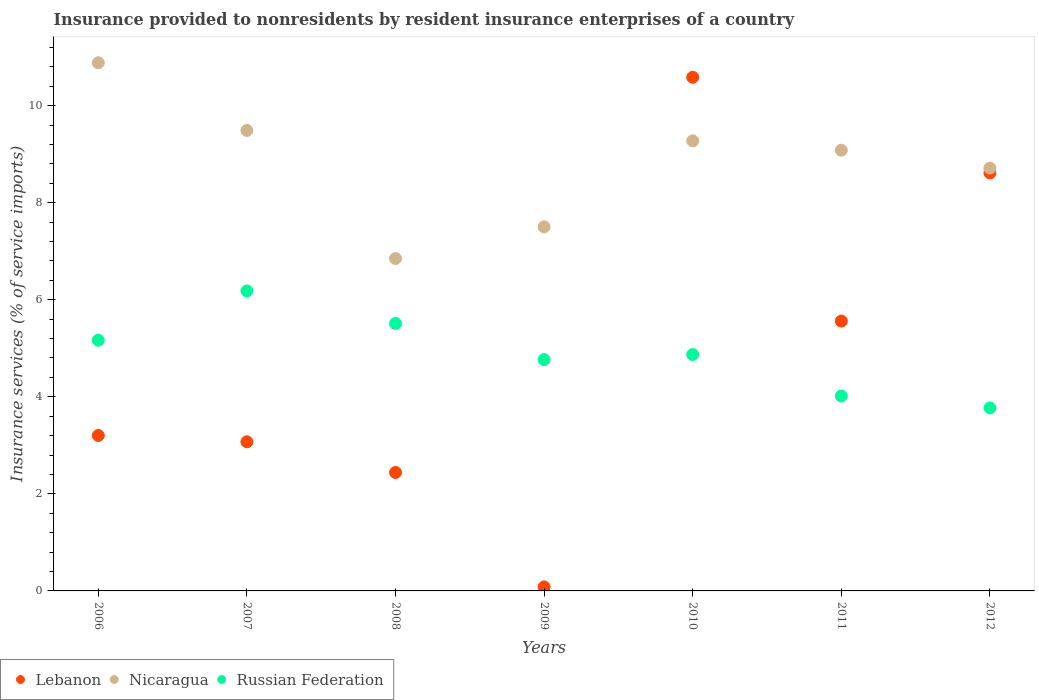How many different coloured dotlines are there?
Give a very brief answer. 3. Is the number of dotlines equal to the number of legend labels?
Ensure brevity in your answer.  Yes. What is the insurance provided to nonresidents in Russian Federation in 2012?
Give a very brief answer. 3.77. Across all years, what is the maximum insurance provided to nonresidents in Nicaragua?
Give a very brief answer. 10.88. Across all years, what is the minimum insurance provided to nonresidents in Russian Federation?
Make the answer very short. 3.77. In which year was the insurance provided to nonresidents in Nicaragua maximum?
Your response must be concise. 2006. In which year was the insurance provided to nonresidents in Lebanon minimum?
Provide a short and direct response. 2009. What is the total insurance provided to nonresidents in Lebanon in the graph?
Your answer should be compact. 33.56. What is the difference between the insurance provided to nonresidents in Lebanon in 2009 and that in 2011?
Your answer should be very brief. -5.48. What is the difference between the insurance provided to nonresidents in Russian Federation in 2009 and the insurance provided to nonresidents in Lebanon in 2012?
Keep it short and to the point. -3.85. What is the average insurance provided to nonresidents in Lebanon per year?
Offer a terse response. 4.79. In the year 2006, what is the difference between the insurance provided to nonresidents in Russian Federation and insurance provided to nonresidents in Lebanon?
Keep it short and to the point. 1.96. In how many years, is the insurance provided to nonresidents in Nicaragua greater than 4.8 %?
Your response must be concise. 7. What is the ratio of the insurance provided to nonresidents in Lebanon in 2006 to that in 2012?
Offer a very short reply. 0.37. Is the difference between the insurance provided to nonresidents in Russian Federation in 2007 and 2011 greater than the difference between the insurance provided to nonresidents in Lebanon in 2007 and 2011?
Offer a terse response. Yes. What is the difference between the highest and the second highest insurance provided to nonresidents in Russian Federation?
Give a very brief answer. 0.67. What is the difference between the highest and the lowest insurance provided to nonresidents in Russian Federation?
Keep it short and to the point. 2.41. In how many years, is the insurance provided to nonresidents in Nicaragua greater than the average insurance provided to nonresidents in Nicaragua taken over all years?
Keep it short and to the point. 4. Is the sum of the insurance provided to nonresidents in Russian Federation in 2010 and 2011 greater than the maximum insurance provided to nonresidents in Nicaragua across all years?
Offer a terse response. No. Is the insurance provided to nonresidents in Russian Federation strictly greater than the insurance provided to nonresidents in Nicaragua over the years?
Your answer should be compact. No. What is the difference between two consecutive major ticks on the Y-axis?
Your response must be concise. 2. Does the graph contain any zero values?
Your answer should be very brief. No. How are the legend labels stacked?
Provide a short and direct response. Horizontal. What is the title of the graph?
Ensure brevity in your answer.  Insurance provided to nonresidents by resident insurance enterprises of a country. Does "Comoros" appear as one of the legend labels in the graph?
Your answer should be very brief. No. What is the label or title of the Y-axis?
Your response must be concise. Insurance services (% of service imports). What is the Insurance services (% of service imports) of Lebanon in 2006?
Give a very brief answer. 3.2. What is the Insurance services (% of service imports) of Nicaragua in 2006?
Make the answer very short. 10.88. What is the Insurance services (% of service imports) of Russian Federation in 2006?
Offer a very short reply. 5.17. What is the Insurance services (% of service imports) of Lebanon in 2007?
Provide a succinct answer. 3.07. What is the Insurance services (% of service imports) in Nicaragua in 2007?
Offer a terse response. 9.49. What is the Insurance services (% of service imports) in Russian Federation in 2007?
Offer a terse response. 6.18. What is the Insurance services (% of service imports) of Lebanon in 2008?
Provide a short and direct response. 2.44. What is the Insurance services (% of service imports) in Nicaragua in 2008?
Provide a succinct answer. 6.85. What is the Insurance services (% of service imports) in Russian Federation in 2008?
Offer a terse response. 5.51. What is the Insurance services (% of service imports) in Lebanon in 2009?
Keep it short and to the point. 0.08. What is the Insurance services (% of service imports) of Nicaragua in 2009?
Keep it short and to the point. 7.5. What is the Insurance services (% of service imports) of Russian Federation in 2009?
Offer a terse response. 4.77. What is the Insurance services (% of service imports) in Lebanon in 2010?
Provide a succinct answer. 10.58. What is the Insurance services (% of service imports) of Nicaragua in 2010?
Give a very brief answer. 9.27. What is the Insurance services (% of service imports) of Russian Federation in 2010?
Your response must be concise. 4.87. What is the Insurance services (% of service imports) in Lebanon in 2011?
Provide a short and direct response. 5.56. What is the Insurance services (% of service imports) of Nicaragua in 2011?
Your answer should be compact. 9.08. What is the Insurance services (% of service imports) in Russian Federation in 2011?
Your answer should be compact. 4.02. What is the Insurance services (% of service imports) of Lebanon in 2012?
Offer a very short reply. 8.61. What is the Insurance services (% of service imports) in Nicaragua in 2012?
Give a very brief answer. 8.71. What is the Insurance services (% of service imports) of Russian Federation in 2012?
Give a very brief answer. 3.77. Across all years, what is the maximum Insurance services (% of service imports) of Lebanon?
Your answer should be compact. 10.58. Across all years, what is the maximum Insurance services (% of service imports) of Nicaragua?
Offer a very short reply. 10.88. Across all years, what is the maximum Insurance services (% of service imports) of Russian Federation?
Provide a short and direct response. 6.18. Across all years, what is the minimum Insurance services (% of service imports) in Lebanon?
Provide a short and direct response. 0.08. Across all years, what is the minimum Insurance services (% of service imports) of Nicaragua?
Provide a succinct answer. 6.85. Across all years, what is the minimum Insurance services (% of service imports) in Russian Federation?
Your response must be concise. 3.77. What is the total Insurance services (% of service imports) in Lebanon in the graph?
Make the answer very short. 33.56. What is the total Insurance services (% of service imports) of Nicaragua in the graph?
Give a very brief answer. 61.79. What is the total Insurance services (% of service imports) in Russian Federation in the graph?
Offer a terse response. 34.29. What is the difference between the Insurance services (% of service imports) in Lebanon in 2006 and that in 2007?
Ensure brevity in your answer.  0.13. What is the difference between the Insurance services (% of service imports) in Nicaragua in 2006 and that in 2007?
Provide a short and direct response. 1.39. What is the difference between the Insurance services (% of service imports) in Russian Federation in 2006 and that in 2007?
Your answer should be very brief. -1.02. What is the difference between the Insurance services (% of service imports) of Lebanon in 2006 and that in 2008?
Provide a succinct answer. 0.76. What is the difference between the Insurance services (% of service imports) in Nicaragua in 2006 and that in 2008?
Your answer should be very brief. 4.03. What is the difference between the Insurance services (% of service imports) of Russian Federation in 2006 and that in 2008?
Give a very brief answer. -0.35. What is the difference between the Insurance services (% of service imports) in Lebanon in 2006 and that in 2009?
Keep it short and to the point. 3.12. What is the difference between the Insurance services (% of service imports) of Nicaragua in 2006 and that in 2009?
Provide a short and direct response. 3.38. What is the difference between the Insurance services (% of service imports) of Russian Federation in 2006 and that in 2009?
Provide a short and direct response. 0.4. What is the difference between the Insurance services (% of service imports) in Lebanon in 2006 and that in 2010?
Offer a very short reply. -7.38. What is the difference between the Insurance services (% of service imports) in Nicaragua in 2006 and that in 2010?
Make the answer very short. 1.61. What is the difference between the Insurance services (% of service imports) of Russian Federation in 2006 and that in 2010?
Keep it short and to the point. 0.3. What is the difference between the Insurance services (% of service imports) in Lebanon in 2006 and that in 2011?
Give a very brief answer. -2.36. What is the difference between the Insurance services (% of service imports) in Nicaragua in 2006 and that in 2011?
Keep it short and to the point. 1.8. What is the difference between the Insurance services (% of service imports) of Russian Federation in 2006 and that in 2011?
Give a very brief answer. 1.15. What is the difference between the Insurance services (% of service imports) in Lebanon in 2006 and that in 2012?
Your answer should be compact. -5.41. What is the difference between the Insurance services (% of service imports) in Nicaragua in 2006 and that in 2012?
Make the answer very short. 2.17. What is the difference between the Insurance services (% of service imports) of Russian Federation in 2006 and that in 2012?
Offer a terse response. 1.4. What is the difference between the Insurance services (% of service imports) in Lebanon in 2007 and that in 2008?
Your answer should be compact. 0.63. What is the difference between the Insurance services (% of service imports) in Nicaragua in 2007 and that in 2008?
Make the answer very short. 2.64. What is the difference between the Insurance services (% of service imports) in Russian Federation in 2007 and that in 2008?
Your response must be concise. 0.67. What is the difference between the Insurance services (% of service imports) of Lebanon in 2007 and that in 2009?
Give a very brief answer. 2.99. What is the difference between the Insurance services (% of service imports) in Nicaragua in 2007 and that in 2009?
Give a very brief answer. 1.99. What is the difference between the Insurance services (% of service imports) in Russian Federation in 2007 and that in 2009?
Offer a terse response. 1.41. What is the difference between the Insurance services (% of service imports) in Lebanon in 2007 and that in 2010?
Provide a succinct answer. -7.51. What is the difference between the Insurance services (% of service imports) in Nicaragua in 2007 and that in 2010?
Your response must be concise. 0.21. What is the difference between the Insurance services (% of service imports) in Russian Federation in 2007 and that in 2010?
Offer a very short reply. 1.31. What is the difference between the Insurance services (% of service imports) of Lebanon in 2007 and that in 2011?
Provide a short and direct response. -2.49. What is the difference between the Insurance services (% of service imports) of Nicaragua in 2007 and that in 2011?
Keep it short and to the point. 0.41. What is the difference between the Insurance services (% of service imports) of Russian Federation in 2007 and that in 2011?
Your answer should be compact. 2.17. What is the difference between the Insurance services (% of service imports) of Lebanon in 2007 and that in 2012?
Your answer should be compact. -5.54. What is the difference between the Insurance services (% of service imports) of Nicaragua in 2007 and that in 2012?
Provide a succinct answer. 0.78. What is the difference between the Insurance services (% of service imports) of Russian Federation in 2007 and that in 2012?
Offer a very short reply. 2.41. What is the difference between the Insurance services (% of service imports) of Lebanon in 2008 and that in 2009?
Provide a succinct answer. 2.36. What is the difference between the Insurance services (% of service imports) in Nicaragua in 2008 and that in 2009?
Your answer should be very brief. -0.65. What is the difference between the Insurance services (% of service imports) of Russian Federation in 2008 and that in 2009?
Make the answer very short. 0.75. What is the difference between the Insurance services (% of service imports) in Lebanon in 2008 and that in 2010?
Your answer should be compact. -8.14. What is the difference between the Insurance services (% of service imports) in Nicaragua in 2008 and that in 2010?
Give a very brief answer. -2.43. What is the difference between the Insurance services (% of service imports) of Russian Federation in 2008 and that in 2010?
Offer a very short reply. 0.64. What is the difference between the Insurance services (% of service imports) of Lebanon in 2008 and that in 2011?
Make the answer very short. -3.12. What is the difference between the Insurance services (% of service imports) in Nicaragua in 2008 and that in 2011?
Keep it short and to the point. -2.23. What is the difference between the Insurance services (% of service imports) of Russian Federation in 2008 and that in 2011?
Your answer should be compact. 1.5. What is the difference between the Insurance services (% of service imports) in Lebanon in 2008 and that in 2012?
Ensure brevity in your answer.  -6.17. What is the difference between the Insurance services (% of service imports) in Nicaragua in 2008 and that in 2012?
Keep it short and to the point. -1.86. What is the difference between the Insurance services (% of service imports) in Russian Federation in 2008 and that in 2012?
Offer a very short reply. 1.74. What is the difference between the Insurance services (% of service imports) in Lebanon in 2009 and that in 2010?
Provide a short and direct response. -10.5. What is the difference between the Insurance services (% of service imports) in Nicaragua in 2009 and that in 2010?
Keep it short and to the point. -1.77. What is the difference between the Insurance services (% of service imports) in Russian Federation in 2009 and that in 2010?
Keep it short and to the point. -0.1. What is the difference between the Insurance services (% of service imports) of Lebanon in 2009 and that in 2011?
Give a very brief answer. -5.48. What is the difference between the Insurance services (% of service imports) of Nicaragua in 2009 and that in 2011?
Keep it short and to the point. -1.58. What is the difference between the Insurance services (% of service imports) in Russian Federation in 2009 and that in 2011?
Your response must be concise. 0.75. What is the difference between the Insurance services (% of service imports) in Lebanon in 2009 and that in 2012?
Keep it short and to the point. -8.53. What is the difference between the Insurance services (% of service imports) of Nicaragua in 2009 and that in 2012?
Your response must be concise. -1.21. What is the difference between the Insurance services (% of service imports) in Russian Federation in 2009 and that in 2012?
Offer a terse response. 1. What is the difference between the Insurance services (% of service imports) of Lebanon in 2010 and that in 2011?
Your answer should be compact. 5.02. What is the difference between the Insurance services (% of service imports) in Nicaragua in 2010 and that in 2011?
Make the answer very short. 0.19. What is the difference between the Insurance services (% of service imports) of Russian Federation in 2010 and that in 2011?
Keep it short and to the point. 0.86. What is the difference between the Insurance services (% of service imports) of Lebanon in 2010 and that in 2012?
Your answer should be very brief. 1.97. What is the difference between the Insurance services (% of service imports) in Nicaragua in 2010 and that in 2012?
Your answer should be very brief. 0.56. What is the difference between the Insurance services (% of service imports) of Russian Federation in 2010 and that in 2012?
Provide a succinct answer. 1.1. What is the difference between the Insurance services (% of service imports) in Lebanon in 2011 and that in 2012?
Provide a succinct answer. -3.05. What is the difference between the Insurance services (% of service imports) of Nicaragua in 2011 and that in 2012?
Your answer should be very brief. 0.37. What is the difference between the Insurance services (% of service imports) of Russian Federation in 2011 and that in 2012?
Provide a short and direct response. 0.24. What is the difference between the Insurance services (% of service imports) in Lebanon in 2006 and the Insurance services (% of service imports) in Nicaragua in 2007?
Offer a very short reply. -6.29. What is the difference between the Insurance services (% of service imports) in Lebanon in 2006 and the Insurance services (% of service imports) in Russian Federation in 2007?
Your response must be concise. -2.98. What is the difference between the Insurance services (% of service imports) in Nicaragua in 2006 and the Insurance services (% of service imports) in Russian Federation in 2007?
Your response must be concise. 4.7. What is the difference between the Insurance services (% of service imports) in Lebanon in 2006 and the Insurance services (% of service imports) in Nicaragua in 2008?
Give a very brief answer. -3.65. What is the difference between the Insurance services (% of service imports) in Lebanon in 2006 and the Insurance services (% of service imports) in Russian Federation in 2008?
Keep it short and to the point. -2.31. What is the difference between the Insurance services (% of service imports) in Nicaragua in 2006 and the Insurance services (% of service imports) in Russian Federation in 2008?
Offer a very short reply. 5.37. What is the difference between the Insurance services (% of service imports) in Lebanon in 2006 and the Insurance services (% of service imports) in Nicaragua in 2009?
Ensure brevity in your answer.  -4.3. What is the difference between the Insurance services (% of service imports) in Lebanon in 2006 and the Insurance services (% of service imports) in Russian Federation in 2009?
Offer a terse response. -1.56. What is the difference between the Insurance services (% of service imports) of Nicaragua in 2006 and the Insurance services (% of service imports) of Russian Federation in 2009?
Offer a terse response. 6.12. What is the difference between the Insurance services (% of service imports) of Lebanon in 2006 and the Insurance services (% of service imports) of Nicaragua in 2010?
Make the answer very short. -6.07. What is the difference between the Insurance services (% of service imports) in Lebanon in 2006 and the Insurance services (% of service imports) in Russian Federation in 2010?
Make the answer very short. -1.67. What is the difference between the Insurance services (% of service imports) in Nicaragua in 2006 and the Insurance services (% of service imports) in Russian Federation in 2010?
Your response must be concise. 6.01. What is the difference between the Insurance services (% of service imports) in Lebanon in 2006 and the Insurance services (% of service imports) in Nicaragua in 2011?
Offer a very short reply. -5.88. What is the difference between the Insurance services (% of service imports) in Lebanon in 2006 and the Insurance services (% of service imports) in Russian Federation in 2011?
Keep it short and to the point. -0.81. What is the difference between the Insurance services (% of service imports) in Nicaragua in 2006 and the Insurance services (% of service imports) in Russian Federation in 2011?
Make the answer very short. 6.87. What is the difference between the Insurance services (% of service imports) of Lebanon in 2006 and the Insurance services (% of service imports) of Nicaragua in 2012?
Your response must be concise. -5.51. What is the difference between the Insurance services (% of service imports) of Lebanon in 2006 and the Insurance services (% of service imports) of Russian Federation in 2012?
Ensure brevity in your answer.  -0.57. What is the difference between the Insurance services (% of service imports) in Nicaragua in 2006 and the Insurance services (% of service imports) in Russian Federation in 2012?
Provide a succinct answer. 7.11. What is the difference between the Insurance services (% of service imports) in Lebanon in 2007 and the Insurance services (% of service imports) in Nicaragua in 2008?
Offer a very short reply. -3.78. What is the difference between the Insurance services (% of service imports) in Lebanon in 2007 and the Insurance services (% of service imports) in Russian Federation in 2008?
Your answer should be very brief. -2.44. What is the difference between the Insurance services (% of service imports) in Nicaragua in 2007 and the Insurance services (% of service imports) in Russian Federation in 2008?
Keep it short and to the point. 3.98. What is the difference between the Insurance services (% of service imports) of Lebanon in 2007 and the Insurance services (% of service imports) of Nicaragua in 2009?
Provide a succinct answer. -4.43. What is the difference between the Insurance services (% of service imports) in Lebanon in 2007 and the Insurance services (% of service imports) in Russian Federation in 2009?
Ensure brevity in your answer.  -1.69. What is the difference between the Insurance services (% of service imports) of Nicaragua in 2007 and the Insurance services (% of service imports) of Russian Federation in 2009?
Your answer should be compact. 4.72. What is the difference between the Insurance services (% of service imports) of Lebanon in 2007 and the Insurance services (% of service imports) of Nicaragua in 2010?
Keep it short and to the point. -6.2. What is the difference between the Insurance services (% of service imports) of Lebanon in 2007 and the Insurance services (% of service imports) of Russian Federation in 2010?
Keep it short and to the point. -1.8. What is the difference between the Insurance services (% of service imports) in Nicaragua in 2007 and the Insurance services (% of service imports) in Russian Federation in 2010?
Provide a succinct answer. 4.62. What is the difference between the Insurance services (% of service imports) of Lebanon in 2007 and the Insurance services (% of service imports) of Nicaragua in 2011?
Offer a terse response. -6.01. What is the difference between the Insurance services (% of service imports) of Lebanon in 2007 and the Insurance services (% of service imports) of Russian Federation in 2011?
Make the answer very short. -0.94. What is the difference between the Insurance services (% of service imports) in Nicaragua in 2007 and the Insurance services (% of service imports) in Russian Federation in 2011?
Provide a succinct answer. 5.47. What is the difference between the Insurance services (% of service imports) in Lebanon in 2007 and the Insurance services (% of service imports) in Nicaragua in 2012?
Your answer should be very brief. -5.64. What is the difference between the Insurance services (% of service imports) of Lebanon in 2007 and the Insurance services (% of service imports) of Russian Federation in 2012?
Your answer should be very brief. -0.7. What is the difference between the Insurance services (% of service imports) in Nicaragua in 2007 and the Insurance services (% of service imports) in Russian Federation in 2012?
Your answer should be very brief. 5.72. What is the difference between the Insurance services (% of service imports) in Lebanon in 2008 and the Insurance services (% of service imports) in Nicaragua in 2009?
Offer a very short reply. -5.06. What is the difference between the Insurance services (% of service imports) in Lebanon in 2008 and the Insurance services (% of service imports) in Russian Federation in 2009?
Give a very brief answer. -2.33. What is the difference between the Insurance services (% of service imports) of Nicaragua in 2008 and the Insurance services (% of service imports) of Russian Federation in 2009?
Offer a terse response. 2.08. What is the difference between the Insurance services (% of service imports) in Lebanon in 2008 and the Insurance services (% of service imports) in Nicaragua in 2010?
Give a very brief answer. -6.83. What is the difference between the Insurance services (% of service imports) of Lebanon in 2008 and the Insurance services (% of service imports) of Russian Federation in 2010?
Provide a succinct answer. -2.43. What is the difference between the Insurance services (% of service imports) in Nicaragua in 2008 and the Insurance services (% of service imports) in Russian Federation in 2010?
Ensure brevity in your answer.  1.98. What is the difference between the Insurance services (% of service imports) in Lebanon in 2008 and the Insurance services (% of service imports) in Nicaragua in 2011?
Keep it short and to the point. -6.64. What is the difference between the Insurance services (% of service imports) in Lebanon in 2008 and the Insurance services (% of service imports) in Russian Federation in 2011?
Offer a very short reply. -1.57. What is the difference between the Insurance services (% of service imports) of Nicaragua in 2008 and the Insurance services (% of service imports) of Russian Federation in 2011?
Give a very brief answer. 2.83. What is the difference between the Insurance services (% of service imports) in Lebanon in 2008 and the Insurance services (% of service imports) in Nicaragua in 2012?
Make the answer very short. -6.27. What is the difference between the Insurance services (% of service imports) of Lebanon in 2008 and the Insurance services (% of service imports) of Russian Federation in 2012?
Provide a short and direct response. -1.33. What is the difference between the Insurance services (% of service imports) in Nicaragua in 2008 and the Insurance services (% of service imports) in Russian Federation in 2012?
Keep it short and to the point. 3.08. What is the difference between the Insurance services (% of service imports) of Lebanon in 2009 and the Insurance services (% of service imports) of Nicaragua in 2010?
Your response must be concise. -9.19. What is the difference between the Insurance services (% of service imports) in Lebanon in 2009 and the Insurance services (% of service imports) in Russian Federation in 2010?
Your answer should be compact. -4.79. What is the difference between the Insurance services (% of service imports) in Nicaragua in 2009 and the Insurance services (% of service imports) in Russian Federation in 2010?
Give a very brief answer. 2.63. What is the difference between the Insurance services (% of service imports) of Lebanon in 2009 and the Insurance services (% of service imports) of Nicaragua in 2011?
Keep it short and to the point. -9. What is the difference between the Insurance services (% of service imports) of Lebanon in 2009 and the Insurance services (% of service imports) of Russian Federation in 2011?
Make the answer very short. -3.93. What is the difference between the Insurance services (% of service imports) in Nicaragua in 2009 and the Insurance services (% of service imports) in Russian Federation in 2011?
Your answer should be very brief. 3.49. What is the difference between the Insurance services (% of service imports) of Lebanon in 2009 and the Insurance services (% of service imports) of Nicaragua in 2012?
Your answer should be very brief. -8.63. What is the difference between the Insurance services (% of service imports) of Lebanon in 2009 and the Insurance services (% of service imports) of Russian Federation in 2012?
Provide a short and direct response. -3.69. What is the difference between the Insurance services (% of service imports) in Nicaragua in 2009 and the Insurance services (% of service imports) in Russian Federation in 2012?
Ensure brevity in your answer.  3.73. What is the difference between the Insurance services (% of service imports) in Lebanon in 2010 and the Insurance services (% of service imports) in Nicaragua in 2011?
Make the answer very short. 1.5. What is the difference between the Insurance services (% of service imports) in Lebanon in 2010 and the Insurance services (% of service imports) in Russian Federation in 2011?
Make the answer very short. 6.57. What is the difference between the Insurance services (% of service imports) of Nicaragua in 2010 and the Insurance services (% of service imports) of Russian Federation in 2011?
Give a very brief answer. 5.26. What is the difference between the Insurance services (% of service imports) in Lebanon in 2010 and the Insurance services (% of service imports) in Nicaragua in 2012?
Provide a succinct answer. 1.87. What is the difference between the Insurance services (% of service imports) of Lebanon in 2010 and the Insurance services (% of service imports) of Russian Federation in 2012?
Your answer should be compact. 6.81. What is the difference between the Insurance services (% of service imports) in Nicaragua in 2010 and the Insurance services (% of service imports) in Russian Federation in 2012?
Keep it short and to the point. 5.5. What is the difference between the Insurance services (% of service imports) of Lebanon in 2011 and the Insurance services (% of service imports) of Nicaragua in 2012?
Your answer should be very brief. -3.15. What is the difference between the Insurance services (% of service imports) of Lebanon in 2011 and the Insurance services (% of service imports) of Russian Federation in 2012?
Your answer should be compact. 1.79. What is the difference between the Insurance services (% of service imports) of Nicaragua in 2011 and the Insurance services (% of service imports) of Russian Federation in 2012?
Your answer should be very brief. 5.31. What is the average Insurance services (% of service imports) in Lebanon per year?
Provide a short and direct response. 4.79. What is the average Insurance services (% of service imports) of Nicaragua per year?
Your answer should be very brief. 8.83. What is the average Insurance services (% of service imports) of Russian Federation per year?
Your response must be concise. 4.9. In the year 2006, what is the difference between the Insurance services (% of service imports) in Lebanon and Insurance services (% of service imports) in Nicaragua?
Give a very brief answer. -7.68. In the year 2006, what is the difference between the Insurance services (% of service imports) in Lebanon and Insurance services (% of service imports) in Russian Federation?
Keep it short and to the point. -1.96. In the year 2006, what is the difference between the Insurance services (% of service imports) in Nicaragua and Insurance services (% of service imports) in Russian Federation?
Offer a very short reply. 5.72. In the year 2007, what is the difference between the Insurance services (% of service imports) in Lebanon and Insurance services (% of service imports) in Nicaragua?
Ensure brevity in your answer.  -6.42. In the year 2007, what is the difference between the Insurance services (% of service imports) in Lebanon and Insurance services (% of service imports) in Russian Federation?
Offer a terse response. -3.11. In the year 2007, what is the difference between the Insurance services (% of service imports) in Nicaragua and Insurance services (% of service imports) in Russian Federation?
Your answer should be very brief. 3.31. In the year 2008, what is the difference between the Insurance services (% of service imports) in Lebanon and Insurance services (% of service imports) in Nicaragua?
Provide a succinct answer. -4.41. In the year 2008, what is the difference between the Insurance services (% of service imports) of Lebanon and Insurance services (% of service imports) of Russian Federation?
Provide a succinct answer. -3.07. In the year 2008, what is the difference between the Insurance services (% of service imports) of Nicaragua and Insurance services (% of service imports) of Russian Federation?
Offer a very short reply. 1.34. In the year 2009, what is the difference between the Insurance services (% of service imports) in Lebanon and Insurance services (% of service imports) in Nicaragua?
Make the answer very short. -7.42. In the year 2009, what is the difference between the Insurance services (% of service imports) in Lebanon and Insurance services (% of service imports) in Russian Federation?
Your answer should be compact. -4.68. In the year 2009, what is the difference between the Insurance services (% of service imports) in Nicaragua and Insurance services (% of service imports) in Russian Federation?
Your answer should be compact. 2.73. In the year 2010, what is the difference between the Insurance services (% of service imports) of Lebanon and Insurance services (% of service imports) of Nicaragua?
Your answer should be compact. 1.31. In the year 2010, what is the difference between the Insurance services (% of service imports) in Lebanon and Insurance services (% of service imports) in Russian Federation?
Keep it short and to the point. 5.71. In the year 2010, what is the difference between the Insurance services (% of service imports) of Nicaragua and Insurance services (% of service imports) of Russian Federation?
Keep it short and to the point. 4.4. In the year 2011, what is the difference between the Insurance services (% of service imports) of Lebanon and Insurance services (% of service imports) of Nicaragua?
Provide a succinct answer. -3.52. In the year 2011, what is the difference between the Insurance services (% of service imports) of Lebanon and Insurance services (% of service imports) of Russian Federation?
Your response must be concise. 1.55. In the year 2011, what is the difference between the Insurance services (% of service imports) of Nicaragua and Insurance services (% of service imports) of Russian Federation?
Keep it short and to the point. 5.07. In the year 2012, what is the difference between the Insurance services (% of service imports) of Lebanon and Insurance services (% of service imports) of Nicaragua?
Offer a very short reply. -0.1. In the year 2012, what is the difference between the Insurance services (% of service imports) in Lebanon and Insurance services (% of service imports) in Russian Federation?
Give a very brief answer. 4.84. In the year 2012, what is the difference between the Insurance services (% of service imports) of Nicaragua and Insurance services (% of service imports) of Russian Federation?
Offer a very short reply. 4.94. What is the ratio of the Insurance services (% of service imports) of Lebanon in 2006 to that in 2007?
Provide a succinct answer. 1.04. What is the ratio of the Insurance services (% of service imports) in Nicaragua in 2006 to that in 2007?
Your response must be concise. 1.15. What is the ratio of the Insurance services (% of service imports) in Russian Federation in 2006 to that in 2007?
Provide a succinct answer. 0.84. What is the ratio of the Insurance services (% of service imports) in Lebanon in 2006 to that in 2008?
Ensure brevity in your answer.  1.31. What is the ratio of the Insurance services (% of service imports) in Nicaragua in 2006 to that in 2008?
Make the answer very short. 1.59. What is the ratio of the Insurance services (% of service imports) of Russian Federation in 2006 to that in 2008?
Provide a succinct answer. 0.94. What is the ratio of the Insurance services (% of service imports) in Lebanon in 2006 to that in 2009?
Your answer should be compact. 38.35. What is the ratio of the Insurance services (% of service imports) of Nicaragua in 2006 to that in 2009?
Provide a short and direct response. 1.45. What is the ratio of the Insurance services (% of service imports) in Russian Federation in 2006 to that in 2009?
Provide a short and direct response. 1.08. What is the ratio of the Insurance services (% of service imports) of Lebanon in 2006 to that in 2010?
Your answer should be compact. 0.3. What is the ratio of the Insurance services (% of service imports) in Nicaragua in 2006 to that in 2010?
Your answer should be very brief. 1.17. What is the ratio of the Insurance services (% of service imports) in Russian Federation in 2006 to that in 2010?
Provide a short and direct response. 1.06. What is the ratio of the Insurance services (% of service imports) of Lebanon in 2006 to that in 2011?
Make the answer very short. 0.58. What is the ratio of the Insurance services (% of service imports) in Nicaragua in 2006 to that in 2011?
Offer a very short reply. 1.2. What is the ratio of the Insurance services (% of service imports) of Russian Federation in 2006 to that in 2011?
Your response must be concise. 1.29. What is the ratio of the Insurance services (% of service imports) of Lebanon in 2006 to that in 2012?
Give a very brief answer. 0.37. What is the ratio of the Insurance services (% of service imports) in Nicaragua in 2006 to that in 2012?
Keep it short and to the point. 1.25. What is the ratio of the Insurance services (% of service imports) in Russian Federation in 2006 to that in 2012?
Keep it short and to the point. 1.37. What is the ratio of the Insurance services (% of service imports) of Lebanon in 2007 to that in 2008?
Ensure brevity in your answer.  1.26. What is the ratio of the Insurance services (% of service imports) of Nicaragua in 2007 to that in 2008?
Your response must be concise. 1.39. What is the ratio of the Insurance services (% of service imports) of Russian Federation in 2007 to that in 2008?
Ensure brevity in your answer.  1.12. What is the ratio of the Insurance services (% of service imports) of Lebanon in 2007 to that in 2009?
Offer a very short reply. 36.79. What is the ratio of the Insurance services (% of service imports) of Nicaragua in 2007 to that in 2009?
Your answer should be very brief. 1.26. What is the ratio of the Insurance services (% of service imports) in Russian Federation in 2007 to that in 2009?
Your answer should be compact. 1.3. What is the ratio of the Insurance services (% of service imports) of Lebanon in 2007 to that in 2010?
Your answer should be compact. 0.29. What is the ratio of the Insurance services (% of service imports) of Nicaragua in 2007 to that in 2010?
Ensure brevity in your answer.  1.02. What is the ratio of the Insurance services (% of service imports) in Russian Federation in 2007 to that in 2010?
Keep it short and to the point. 1.27. What is the ratio of the Insurance services (% of service imports) in Lebanon in 2007 to that in 2011?
Your answer should be very brief. 0.55. What is the ratio of the Insurance services (% of service imports) in Nicaragua in 2007 to that in 2011?
Offer a very short reply. 1.04. What is the ratio of the Insurance services (% of service imports) of Russian Federation in 2007 to that in 2011?
Offer a very short reply. 1.54. What is the ratio of the Insurance services (% of service imports) of Lebanon in 2007 to that in 2012?
Provide a short and direct response. 0.36. What is the ratio of the Insurance services (% of service imports) in Nicaragua in 2007 to that in 2012?
Make the answer very short. 1.09. What is the ratio of the Insurance services (% of service imports) of Russian Federation in 2007 to that in 2012?
Your answer should be compact. 1.64. What is the ratio of the Insurance services (% of service imports) of Lebanon in 2008 to that in 2009?
Ensure brevity in your answer.  29.23. What is the ratio of the Insurance services (% of service imports) in Nicaragua in 2008 to that in 2009?
Your response must be concise. 0.91. What is the ratio of the Insurance services (% of service imports) of Russian Federation in 2008 to that in 2009?
Keep it short and to the point. 1.16. What is the ratio of the Insurance services (% of service imports) in Lebanon in 2008 to that in 2010?
Make the answer very short. 0.23. What is the ratio of the Insurance services (% of service imports) of Nicaragua in 2008 to that in 2010?
Offer a very short reply. 0.74. What is the ratio of the Insurance services (% of service imports) in Russian Federation in 2008 to that in 2010?
Your answer should be very brief. 1.13. What is the ratio of the Insurance services (% of service imports) of Lebanon in 2008 to that in 2011?
Ensure brevity in your answer.  0.44. What is the ratio of the Insurance services (% of service imports) of Nicaragua in 2008 to that in 2011?
Offer a terse response. 0.75. What is the ratio of the Insurance services (% of service imports) in Russian Federation in 2008 to that in 2011?
Your answer should be very brief. 1.37. What is the ratio of the Insurance services (% of service imports) of Lebanon in 2008 to that in 2012?
Give a very brief answer. 0.28. What is the ratio of the Insurance services (% of service imports) in Nicaragua in 2008 to that in 2012?
Your answer should be very brief. 0.79. What is the ratio of the Insurance services (% of service imports) of Russian Federation in 2008 to that in 2012?
Your answer should be very brief. 1.46. What is the ratio of the Insurance services (% of service imports) in Lebanon in 2009 to that in 2010?
Provide a succinct answer. 0.01. What is the ratio of the Insurance services (% of service imports) in Nicaragua in 2009 to that in 2010?
Your response must be concise. 0.81. What is the ratio of the Insurance services (% of service imports) of Russian Federation in 2009 to that in 2010?
Offer a terse response. 0.98. What is the ratio of the Insurance services (% of service imports) of Lebanon in 2009 to that in 2011?
Ensure brevity in your answer.  0.01. What is the ratio of the Insurance services (% of service imports) of Nicaragua in 2009 to that in 2011?
Make the answer very short. 0.83. What is the ratio of the Insurance services (% of service imports) of Russian Federation in 2009 to that in 2011?
Ensure brevity in your answer.  1.19. What is the ratio of the Insurance services (% of service imports) in Lebanon in 2009 to that in 2012?
Keep it short and to the point. 0.01. What is the ratio of the Insurance services (% of service imports) in Nicaragua in 2009 to that in 2012?
Your answer should be compact. 0.86. What is the ratio of the Insurance services (% of service imports) of Russian Federation in 2009 to that in 2012?
Keep it short and to the point. 1.26. What is the ratio of the Insurance services (% of service imports) in Lebanon in 2010 to that in 2011?
Offer a terse response. 1.9. What is the ratio of the Insurance services (% of service imports) of Nicaragua in 2010 to that in 2011?
Your answer should be very brief. 1.02. What is the ratio of the Insurance services (% of service imports) of Russian Federation in 2010 to that in 2011?
Your response must be concise. 1.21. What is the ratio of the Insurance services (% of service imports) of Lebanon in 2010 to that in 2012?
Provide a succinct answer. 1.23. What is the ratio of the Insurance services (% of service imports) in Nicaragua in 2010 to that in 2012?
Offer a very short reply. 1.06. What is the ratio of the Insurance services (% of service imports) of Russian Federation in 2010 to that in 2012?
Your answer should be very brief. 1.29. What is the ratio of the Insurance services (% of service imports) of Lebanon in 2011 to that in 2012?
Give a very brief answer. 0.65. What is the ratio of the Insurance services (% of service imports) of Nicaragua in 2011 to that in 2012?
Provide a short and direct response. 1.04. What is the ratio of the Insurance services (% of service imports) of Russian Federation in 2011 to that in 2012?
Keep it short and to the point. 1.06. What is the difference between the highest and the second highest Insurance services (% of service imports) in Lebanon?
Your answer should be compact. 1.97. What is the difference between the highest and the second highest Insurance services (% of service imports) of Nicaragua?
Ensure brevity in your answer.  1.39. What is the difference between the highest and the second highest Insurance services (% of service imports) in Russian Federation?
Keep it short and to the point. 0.67. What is the difference between the highest and the lowest Insurance services (% of service imports) of Lebanon?
Your answer should be very brief. 10.5. What is the difference between the highest and the lowest Insurance services (% of service imports) in Nicaragua?
Your answer should be very brief. 4.03. What is the difference between the highest and the lowest Insurance services (% of service imports) in Russian Federation?
Provide a short and direct response. 2.41. 